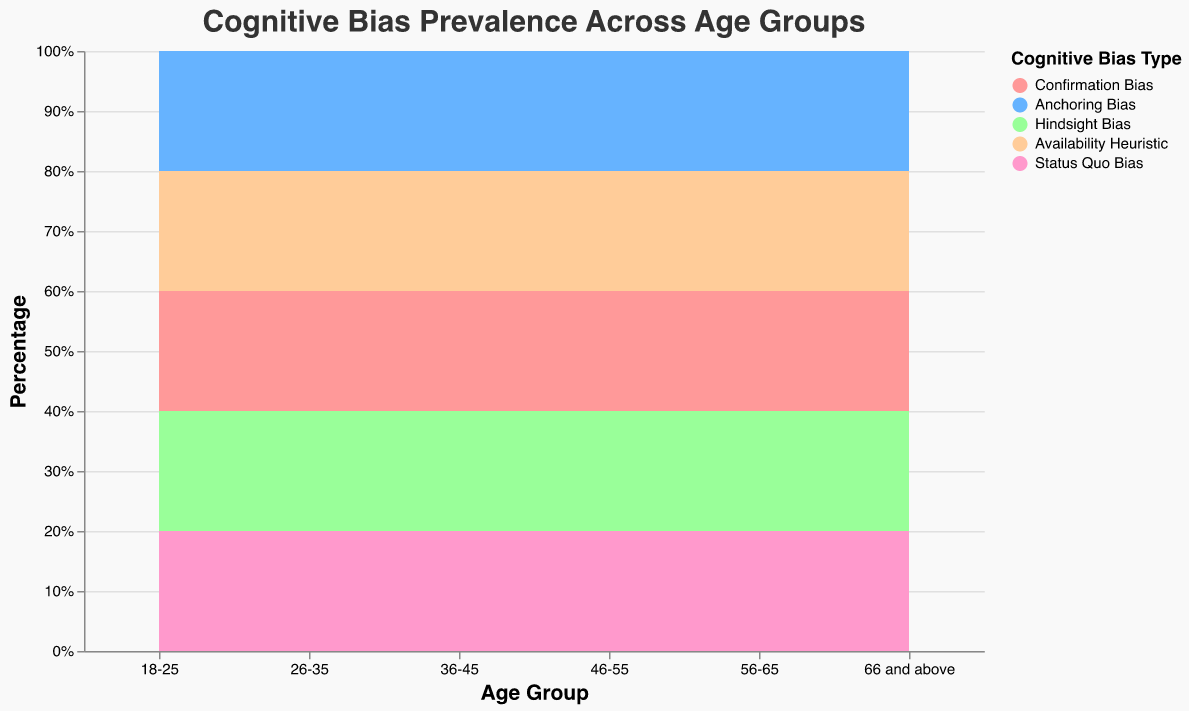Which age group has the highest prevalence of Anchoring Bias? By examining the stacked area chart, we observe that the age group 46-55 has the highest percentage for Anchoring Bias, indicated by the relatively larger segment for this bias.
Answer: 46-55 What is the color used to represent Availability Heuristic? The legend on the right side of the chart indicates that the color associated with Availability Heuristic is a shade of orange.
Answer: Orange Which cognitive bias is most prevalent in the 66 and above age group? The area for Hindsight Bias in the 66 and above age group is the largest, indicating it is the most prevalent bias in this group.
Answer: Hindsight Bias How does the prevalence of Status Quo Bias compare between the 18-25 and 36-45 age groups? The chart shows that the segment for Status Quo Bias is slightly larger for the 18-25 age group compared to the 36-45 age group.
Answer: Higher in 18-25 In which age group does Confirmation Bias decrease the most compared to the previous age group? Looking at the change in the area representing Confirmation Bias between adjacent age groups, the largest decrease occurs between the 36-45 and 46-55 age groups.
Answer: 46-55 Calculate the percentage of cognitive biases other than Confirmation Bias for the 26-35 age group. For the 26-35 age group, the other biases are summed as follows: 22 (Anchoring) + 18 (Hindsight) + 20 (Availability) + 12 (Status Quo) = 72%. Hence, the percentage of biases other than Confirmation Bias is 72%.
Answer: 72% Compare the prevalence of Hindsight Bias and Availability Heuristic for the 56-65 age group. Referring to the chart, the segment for Hindsight Bias is larger than that for Availability Heuristic in the 56-65 age group.
Answer: Higher for Hindsight Bias Identify the age group where Status Quo Bias has the lowest prevalence. The smallest area segment for Status Quo Bias is in the 36-45 age group.
Answer: 36-45 What general trend can be observed for the prevalence of Confirmation Bias across different age groups? The area for Confirmation Bias generally decreases as age increases, showing that it is less prevalent in older age groups.
Answer: Decreases with age Does any age group have Availability Heuristic as the most prevalent cognitive bias? Analyzing the chart, no age group has Availability Heuristic as the most prevalent cognitive bias, though it becomes more significant in older groups.
Answer: No 